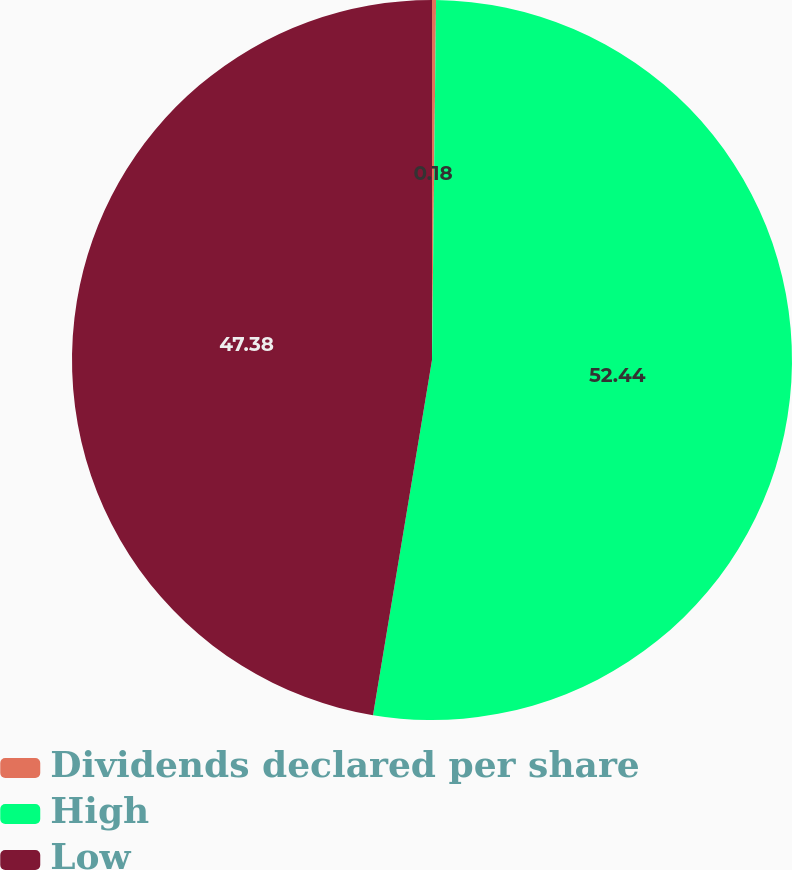<chart> <loc_0><loc_0><loc_500><loc_500><pie_chart><fcel>Dividends declared per share<fcel>High<fcel>Low<nl><fcel>0.18%<fcel>52.44%<fcel>47.38%<nl></chart> 